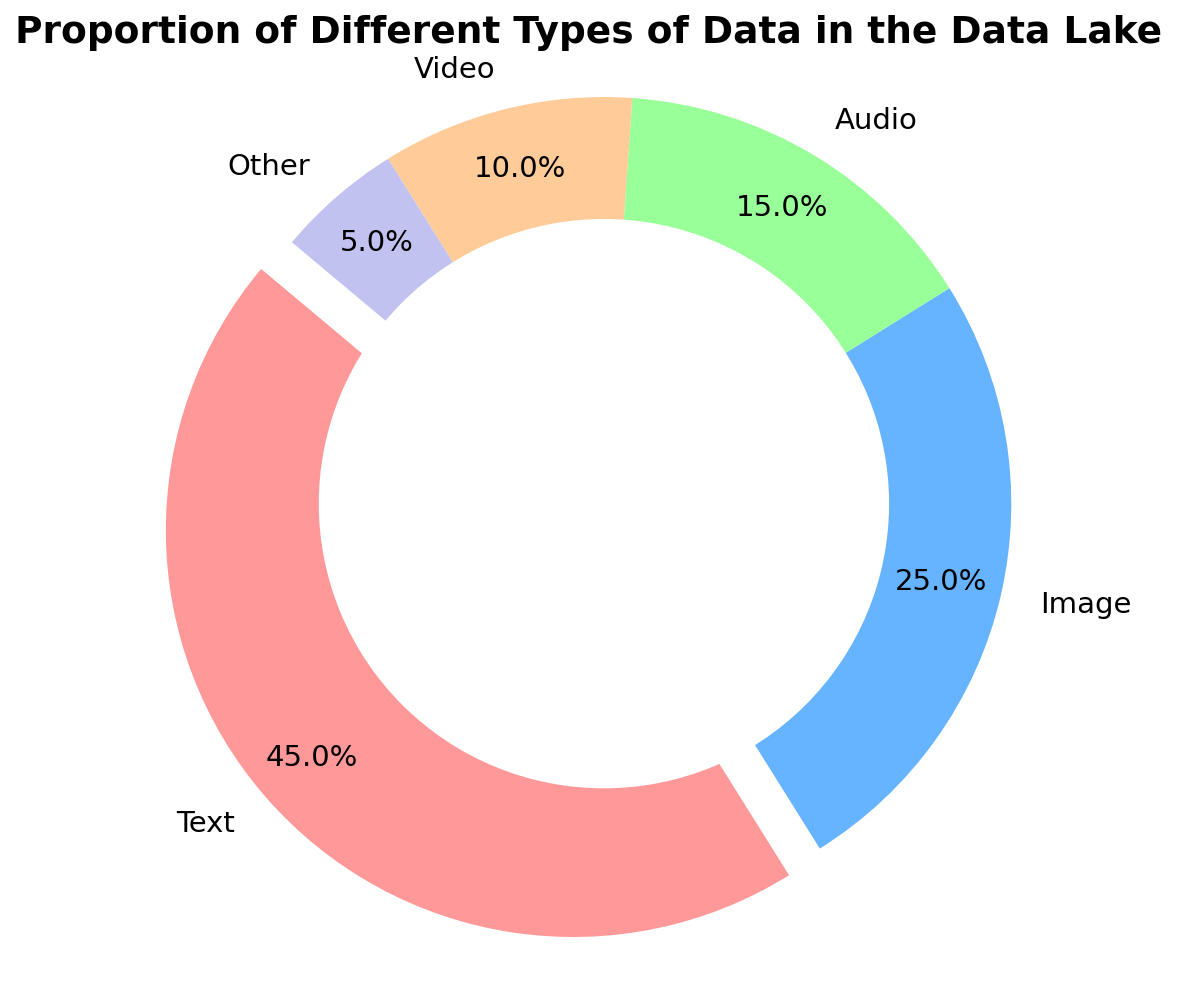What is the category with the highest proportion? The chart shows that the category with the largest segment is "Text," which is also exploded for emphasis.
Answer: Text What percentage of the data lake consists of Audio and Image data combined? From the figure, the proportion of Audio data is 15% and Image data is 25%. Summing these, we get 15% + 25% = 40%.
Answer: 40% Which data type has a smaller proportion than Audio but greater than Other? According to the pie chart, the proportion for Video (10%) is smaller than Audio (15%) yet greater than Other (5%).
Answer: Video What is the difference in proportion between Text and Video data? The proportion of Text data is 45%, while that of Video is 10%. The difference between them is 45% - 10% = 35%.
Answer: 35% What combined proportion of the data lake is made up of Image, Audio, and Other data? Adding the proportions for Image (25%), Audio (15%), and Other (5%), we get 25% + 15% + 5% = 45%.
Answer: 45% Which segment represents 15% of the data lake? Observing the segments and their labels, the one representing 15% is Audio.
Answer: Audio How much greater is the proportion of Text data compared to Image data? The chart shows that Text data is 45% and Image data is 25%. The difference is 45% - 25% = 20%.
Answer: 20% What color represents the "Other" category? The color of the segment labeled "Other" is observed visually and is light purple.
Answer: Light purple Which two data types together constitute half of the data lake? Summing the two largest proportions, Text (45%) and Image (25%), we get 45% + 25% = 70%, thus not matching 50%. Summing Image (25%) and Audio (15%) results in 40%, still not matching. Only when Text (45%) is combined with Other (5%), it sums to exactly 50%.
Answer: Text and Other If we were to equally distribute the data proportion of Text into the three lower proportion categories (Audio, Video, and Other), what would be the new proportion for each of those three? The proportion of Text is 45%. Dividing this equally between Audio (15%), Video (10%), and Other (5%) categories gives 45%/3 = 15% each. Adding this to their original proportions provides: Audio: 15% + 15% = 30%, Video: 10% + 15% = 25%, Other: 5% + 15% = 20%.
Answer: Audio: 30%, Video: 25%, Other: 20% 